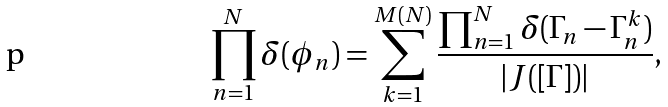Convert formula to latex. <formula><loc_0><loc_0><loc_500><loc_500>\prod _ { n = 1 } ^ { N } \delta ( \phi _ { n } ) = \sum _ { k = 1 } ^ { M ( N ) } \frac { \prod _ { n = 1 } ^ { N } \delta ( \Gamma _ { n } - \Gamma _ { n } ^ { k } ) } { | J ( [ \Gamma ] ) | } ,</formula> 